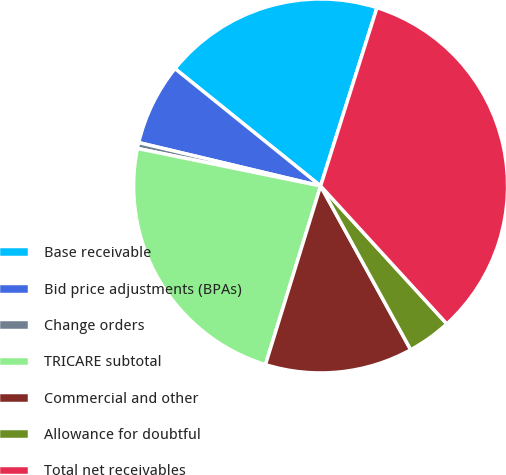Convert chart to OTSL. <chart><loc_0><loc_0><loc_500><loc_500><pie_chart><fcel>Base receivable<fcel>Bid price adjustments (BPAs)<fcel>Change orders<fcel>TRICARE subtotal<fcel>Commercial and other<fcel>Allowance for doubtful<fcel>Total net receivables<nl><fcel>19.08%<fcel>7.07%<fcel>0.51%<fcel>23.45%<fcel>12.77%<fcel>3.79%<fcel>33.33%<nl></chart> 